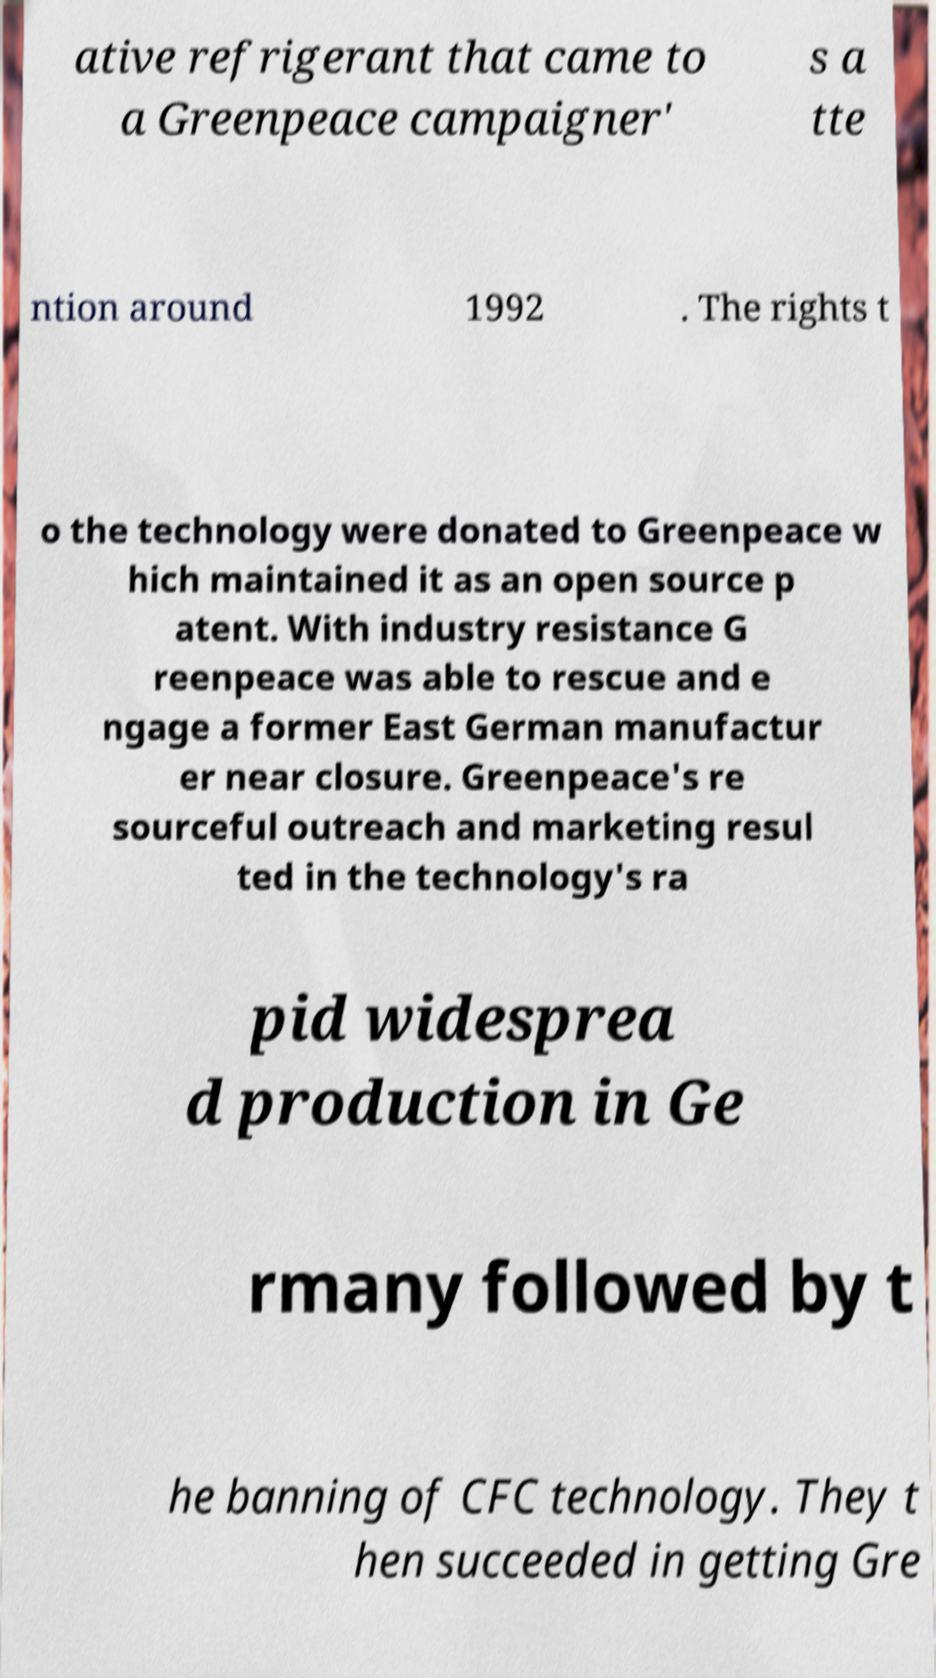Can you accurately transcribe the text from the provided image for me? ative refrigerant that came to a Greenpeace campaigner' s a tte ntion around 1992 . The rights t o the technology were donated to Greenpeace w hich maintained it as an open source p atent. With industry resistance G reenpeace was able to rescue and e ngage a former East German manufactur er near closure. Greenpeace's re sourceful outreach and marketing resul ted in the technology's ra pid widesprea d production in Ge rmany followed by t he banning of CFC technology. They t hen succeeded in getting Gre 